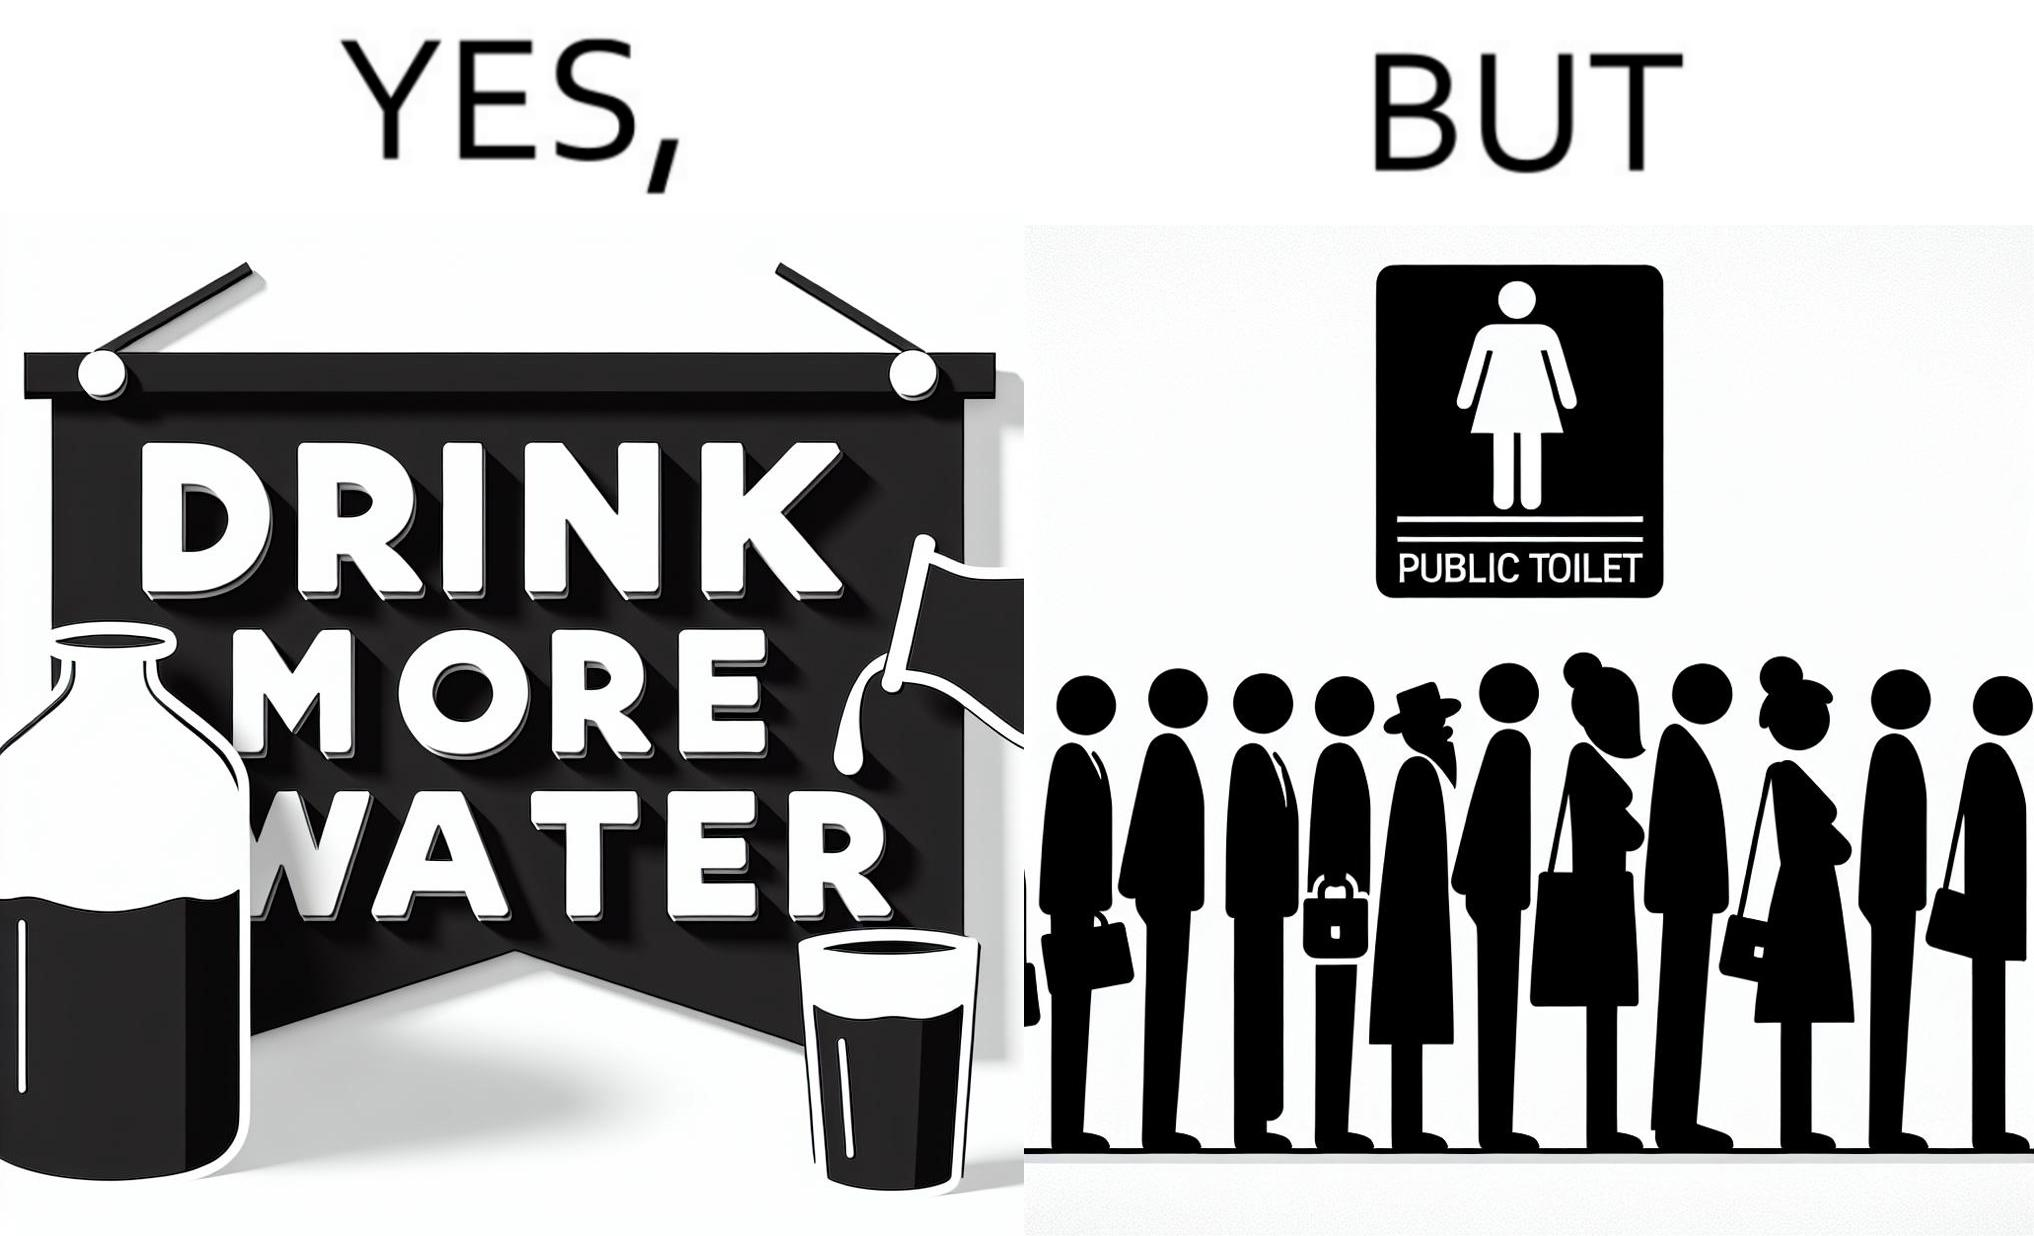What is the satirical meaning behind this image? The image is ironical, as the message "Drink more water" is meant to improve health, but in turn, it would lead to longer queues in front of public toilets, leading to people holding urine for longer periods, in turn leading to deterioration in health. 